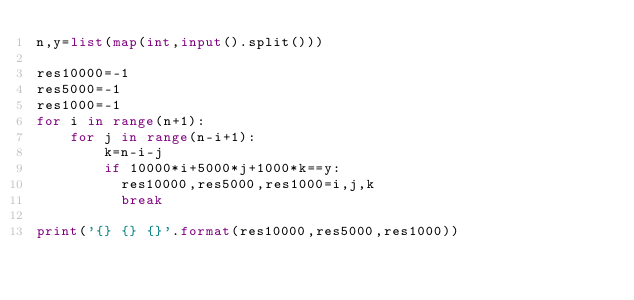<code> <loc_0><loc_0><loc_500><loc_500><_Python_>n,y=list(map(int,input().split()))

res10000=-1
res5000=-1
res1000=-1
for i in range(n+1):
    for j in range(n-i+1):
        k=n-i-j
        if 10000*i+5000*j+1000*k==y:
          res10000,res5000,res1000=i,j,k
          break

print('{} {} {}'.format(res10000,res5000,res1000))</code> 